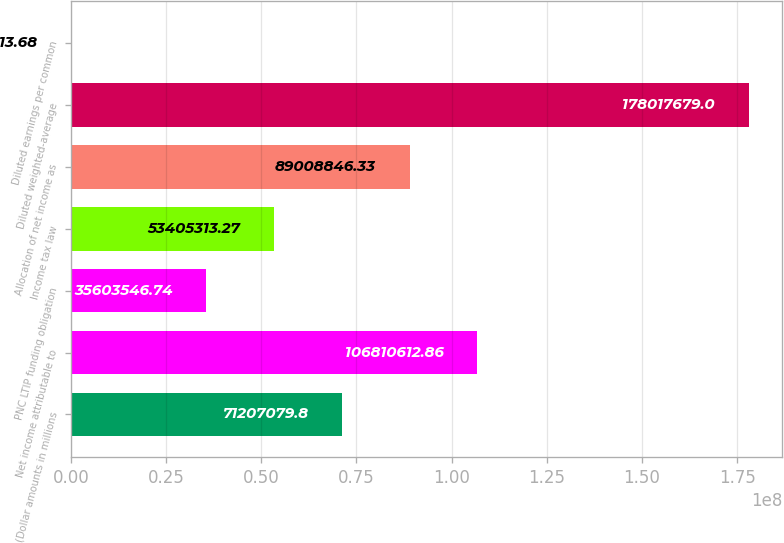<chart> <loc_0><loc_0><loc_500><loc_500><bar_chart><fcel>(Dollar amounts in millions<fcel>Net income attributable to<fcel>PNC LTIP funding obligation<fcel>Income tax law<fcel>Allocation of net income as<fcel>Diluted weighted-average<fcel>Diluted earnings per common<nl><fcel>7.12071e+07<fcel>1.06811e+08<fcel>3.56035e+07<fcel>5.34053e+07<fcel>8.90088e+07<fcel>1.78018e+08<fcel>13.68<nl></chart> 